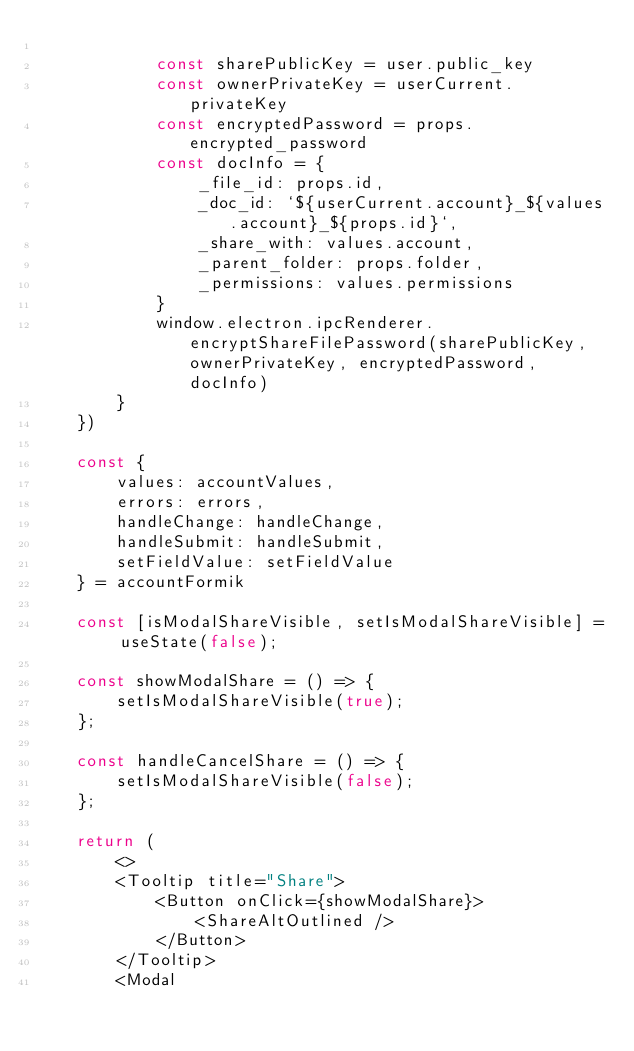<code> <loc_0><loc_0><loc_500><loc_500><_JavaScript_>
            const sharePublicKey = user.public_key
            const ownerPrivateKey = userCurrent.privateKey
            const encryptedPassword = props.encrypted_password
            const docInfo = {
                _file_id: props.id, 
                _doc_id: `${userCurrent.account}_${values.account}_${props.id}`, 
                _share_with: values.account, 
                _parent_folder: props.folder, 
                _permissions: values.permissions
            }
            window.electron.ipcRenderer.encryptShareFilePassword(sharePublicKey, ownerPrivateKey, encryptedPassword, docInfo)
        }
    })

    const {
        values: accountValues, 
        errors: errors, 
        handleChange: handleChange, 
        handleSubmit: handleSubmit, 
        setFieldValue: setFieldValue
    } = accountFormik

    const [isModalShareVisible, setIsModalShareVisible] = useState(false);

    const showModalShare = () => {
        setIsModalShareVisible(true);
    };
    
    const handleCancelShare = () => {
        setIsModalShareVisible(false);
    };

    return (
        <>
        <Tooltip title="Share">
            <Button onClick={showModalShare}>
                <ShareAltOutlined />
            </Button>
        </Tooltip>
        <Modal </code> 